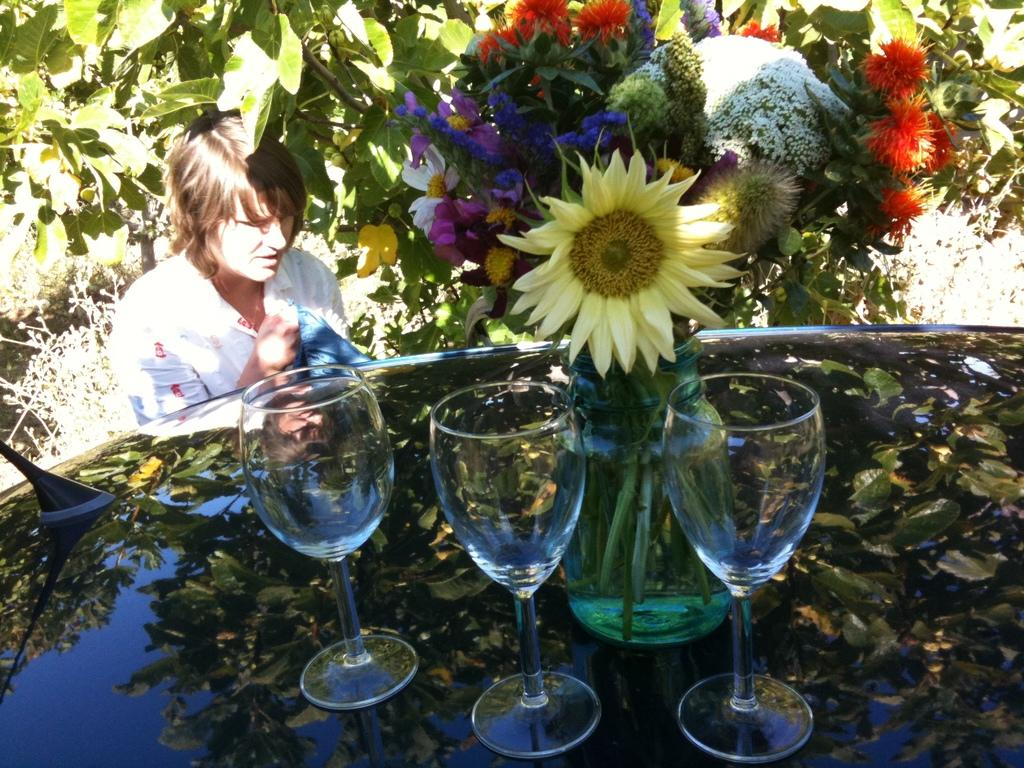What objects can be seen in the image? There are glasses and a jar with flowers in the image. Where are the glasses and flowers located? They are on the car roof in the image. What else can be seen in the background of the image? There is a person, plants, and trees in the background of the image. What type of mouth can be seen on the car in the image? There is no mouth present on the car in the image. What tool is being used to fix the car's route in the image? There is no tool or mention of a route being fixed in the image. 